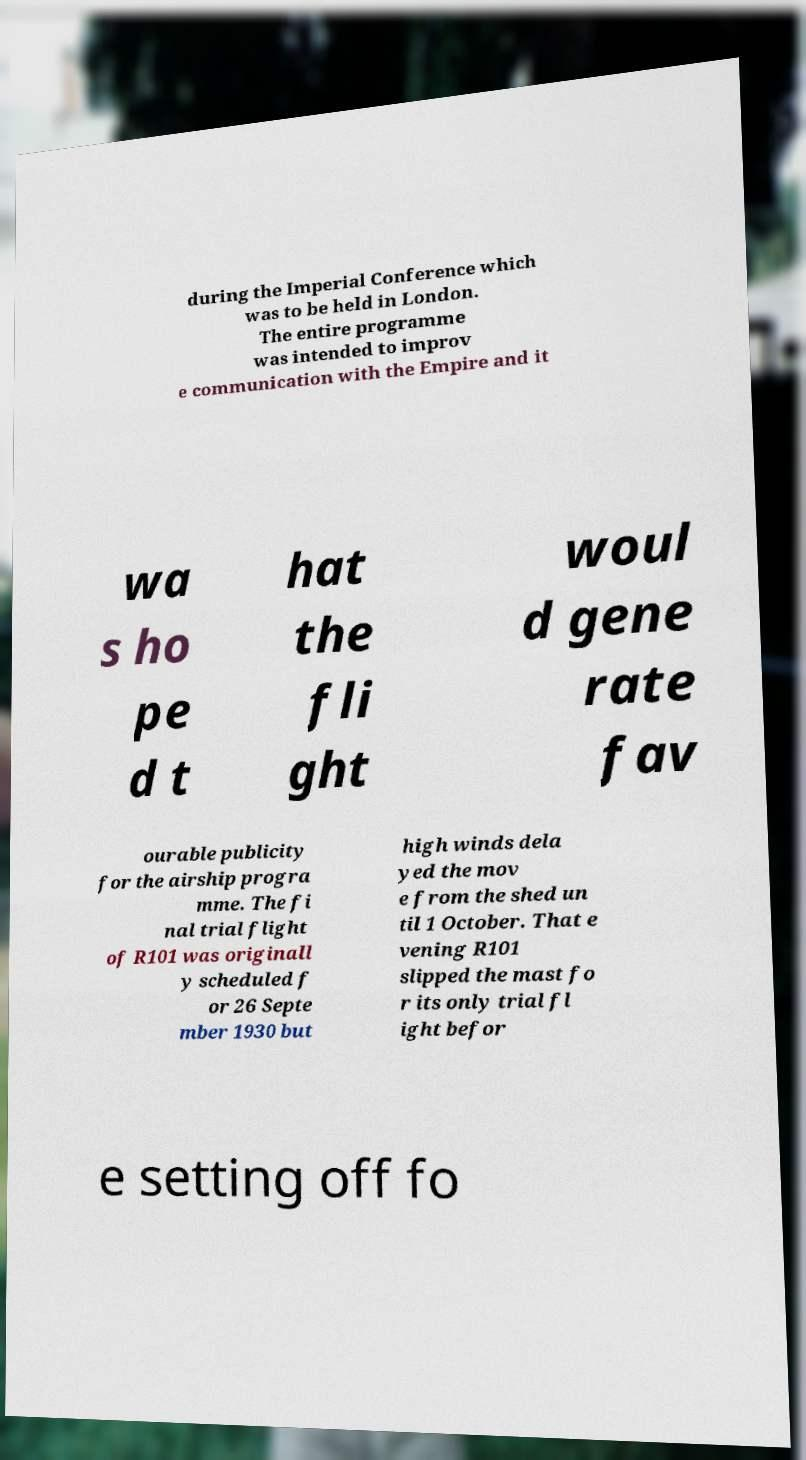For documentation purposes, I need the text within this image transcribed. Could you provide that? during the Imperial Conference which was to be held in London. The entire programme was intended to improv e communication with the Empire and it wa s ho pe d t hat the fli ght woul d gene rate fav ourable publicity for the airship progra mme. The fi nal trial flight of R101 was originall y scheduled f or 26 Septe mber 1930 but high winds dela yed the mov e from the shed un til 1 October. That e vening R101 slipped the mast fo r its only trial fl ight befor e setting off fo 